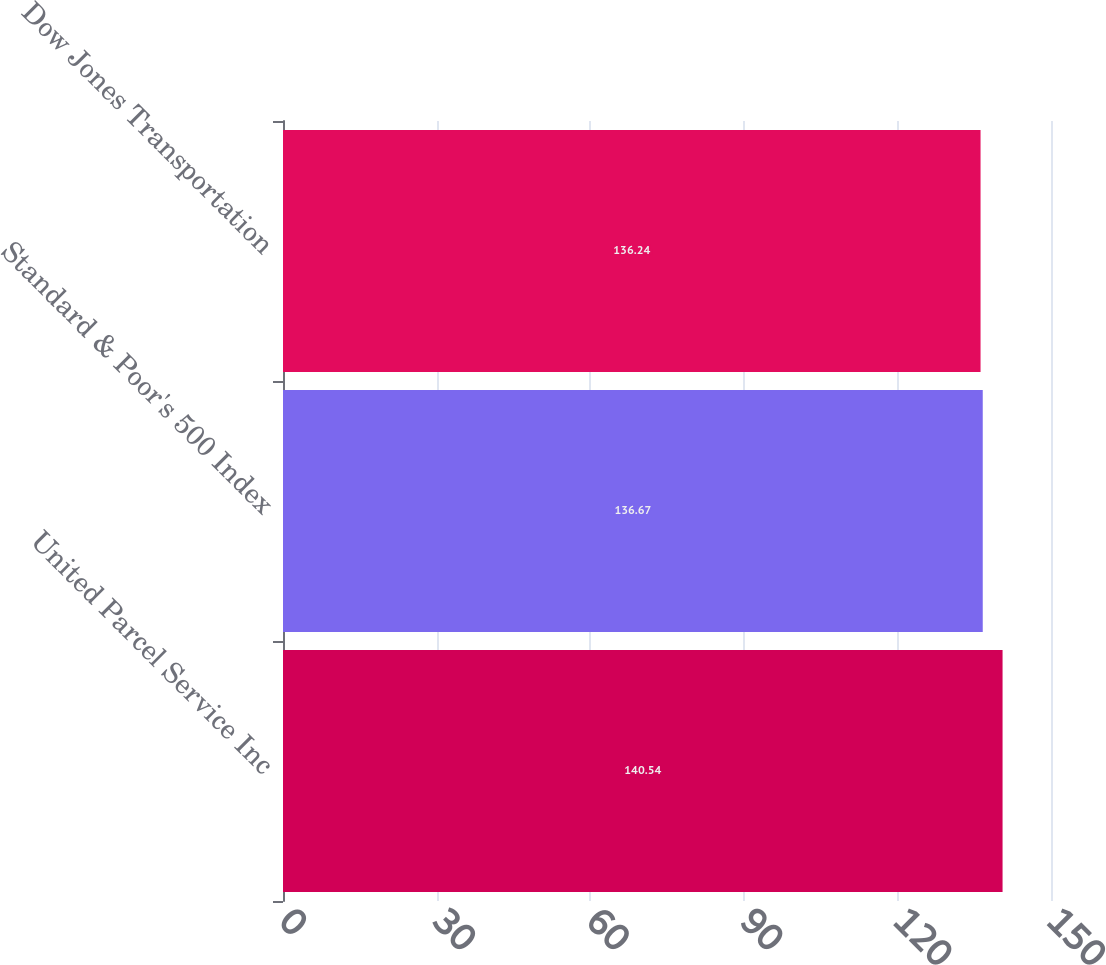Convert chart to OTSL. <chart><loc_0><loc_0><loc_500><loc_500><bar_chart><fcel>United Parcel Service Inc<fcel>Standard & Poor's 500 Index<fcel>Dow Jones Transportation<nl><fcel>140.54<fcel>136.67<fcel>136.24<nl></chart> 